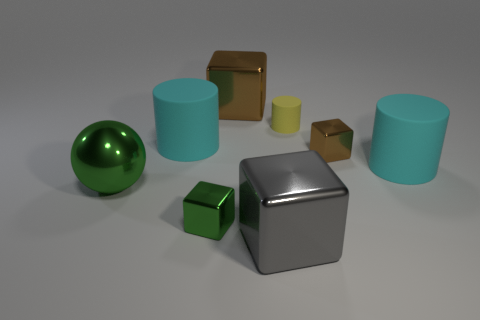Is the shape of the tiny object on the left side of the yellow matte thing the same as the cyan rubber thing to the right of the big brown metallic object?
Make the answer very short. No. Are there any large green spheres made of the same material as the tiny cylinder?
Your answer should be compact. No. What number of green objects are tiny metallic objects or metal cubes?
Make the answer very short. 1. There is a rubber cylinder that is behind the small brown thing and in front of the yellow matte cylinder; what is its size?
Give a very brief answer. Large. Is the number of large cyan objects that are behind the small cylinder greater than the number of blue shiny objects?
Offer a terse response. No. How many cubes are either brown metal objects or tiny green things?
Give a very brief answer. 3. The large shiny thing that is in front of the yellow cylinder and behind the gray block has what shape?
Offer a terse response. Sphere. Are there an equal number of yellow matte things left of the small brown metallic thing and small yellow things that are in front of the tiny yellow object?
Your answer should be very brief. No. How many things are either cyan rubber cylinders or blue metal blocks?
Ensure brevity in your answer.  2. What is the color of the shiny block that is the same size as the gray object?
Your response must be concise. Brown. 